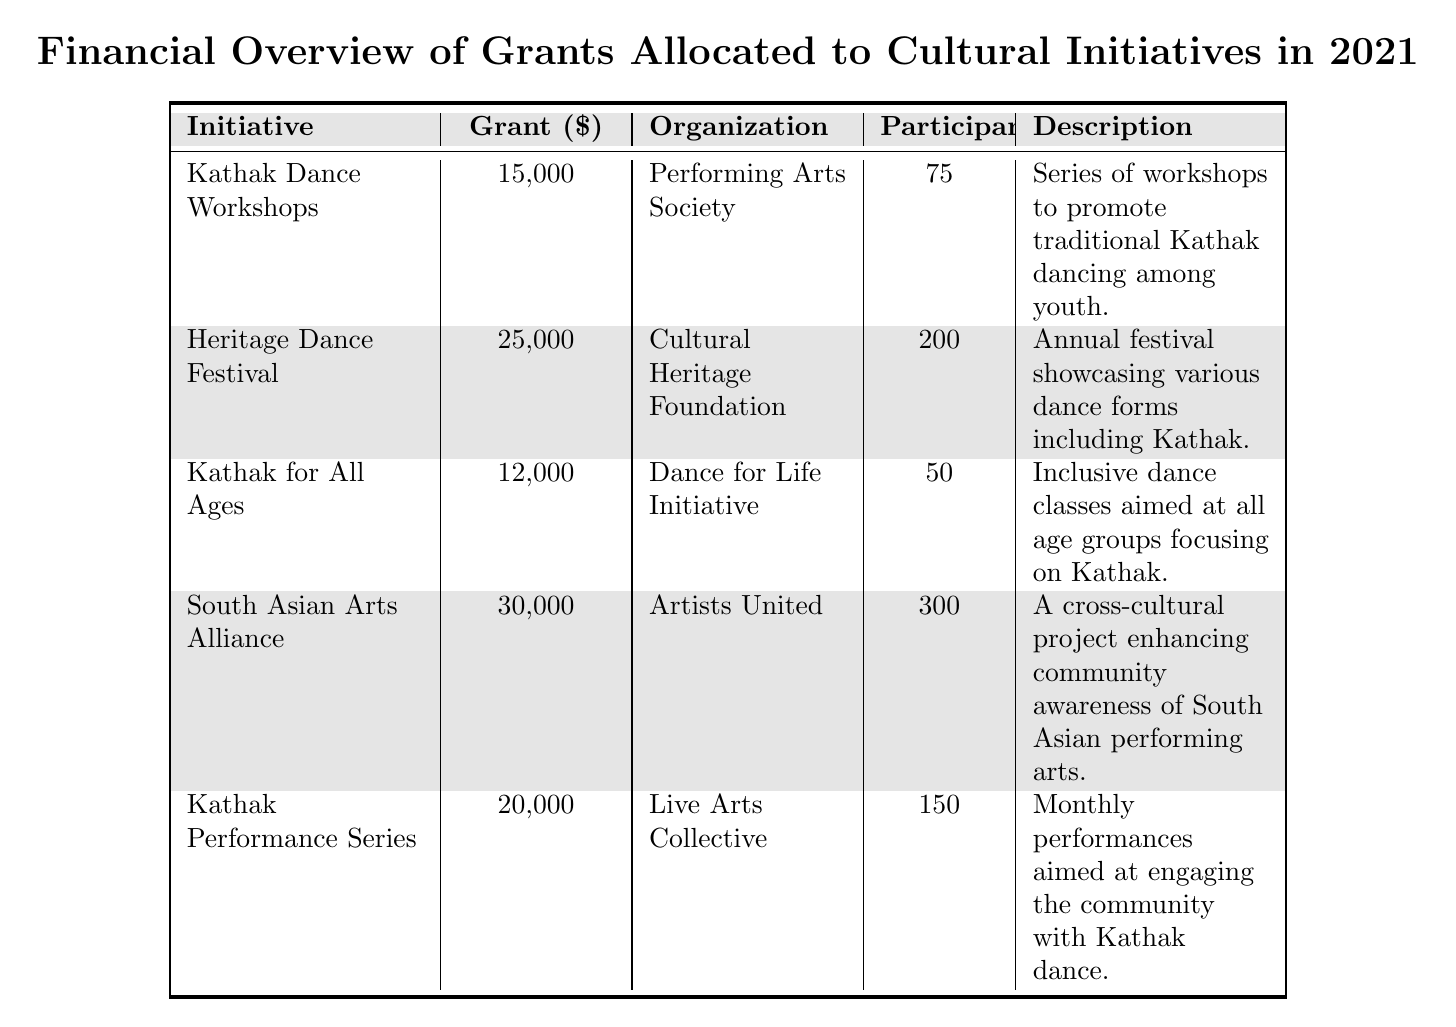What is the total grant amount allocated to Kathak-related initiatives? The initiatives related to Kathak are "Kathak Dance Workshops," "Kathak for All Ages," and "Kathak Performance Series." Their grant amounts are 15,000, 12,000, and 20,000 respectively. Adding these together: 15,000 + 12,000 + 20,000 = 47,000.
Answer: 47,000 Which initiative has the highest grant amount? The initiative with the highest grant amount can be determined by comparing the grant amounts listed. The "South Asian Arts Alliance" has the highest amount at 30,000, compared to the others.
Answer: South Asian Arts Alliance How many total participants are involved in the Cultural Initiatives listed in the table? To find the total participants, add the participants from each initiative: 75 (Kathak Dance Workshops) + 200 (Heritage Dance Festival) + 50 (Kathak for All Ages) + 300 (South Asian Arts Alliance) + 150 (Kathak Performance Series) = 775.
Answer: 775 Is the "Kathak for All Ages" initiative receiving more than 10,000 in grant money? The grant for "Kathak for All Ages" is listed as 12,000. Since 12,000 is greater than 10,000, the statement is true.
Answer: Yes What percentage of the total grant amount is allocated to "Heritage Dance Festival"? The total grant amount is 15,000 + 25,000 + 12,000 + 30,000 + 20,000 = 112,000. The grant for "Heritage Dance Festival" is 25,000. To find the percentage: (25,000 / 112,000) * 100 = 22.32%.
Answer: 22.32% Which grant recipient is associated with the largest number of participants? The initiative with the largest number of participants is "South Asian Arts Alliance" with 300 participants, which is more than all the other initiatives.
Answer: Artists United What is the average grant amount for the Kathak-related initiatives? The total grant amounts for Kathak-related initiatives are 15,000, 12,000, and 20,000, which total 47,000. There are 3 initiatives, so the average is 47,000 / 3 = 15,666.67.
Answer: 15,666.67 Which initiative focuses on promoting Kathak among youth? The "Kathak Dance Workshops" specifically focuses on promoting traditional Kathak dancing among youth according to its description.
Answer: Kathak Dance Workshops What is the combined grant amount for initiatives that focus on inclusivity or accessibility? The relevant initiatives are "Kathak for All Ages" (12,000) and "South Asian Arts Alliance" (30,000). The combined grant amount is 12,000 + 30,000 = 42,000.
Answer: 42,000 Does the "Kathak Performance Series" have more participants than the "Kathak for All Ages"? "Kathak Performance Series" has 150 participants, while "Kathak for All Ages" has 50. Since 150 is greater than 50, the statement is true.
Answer: Yes 